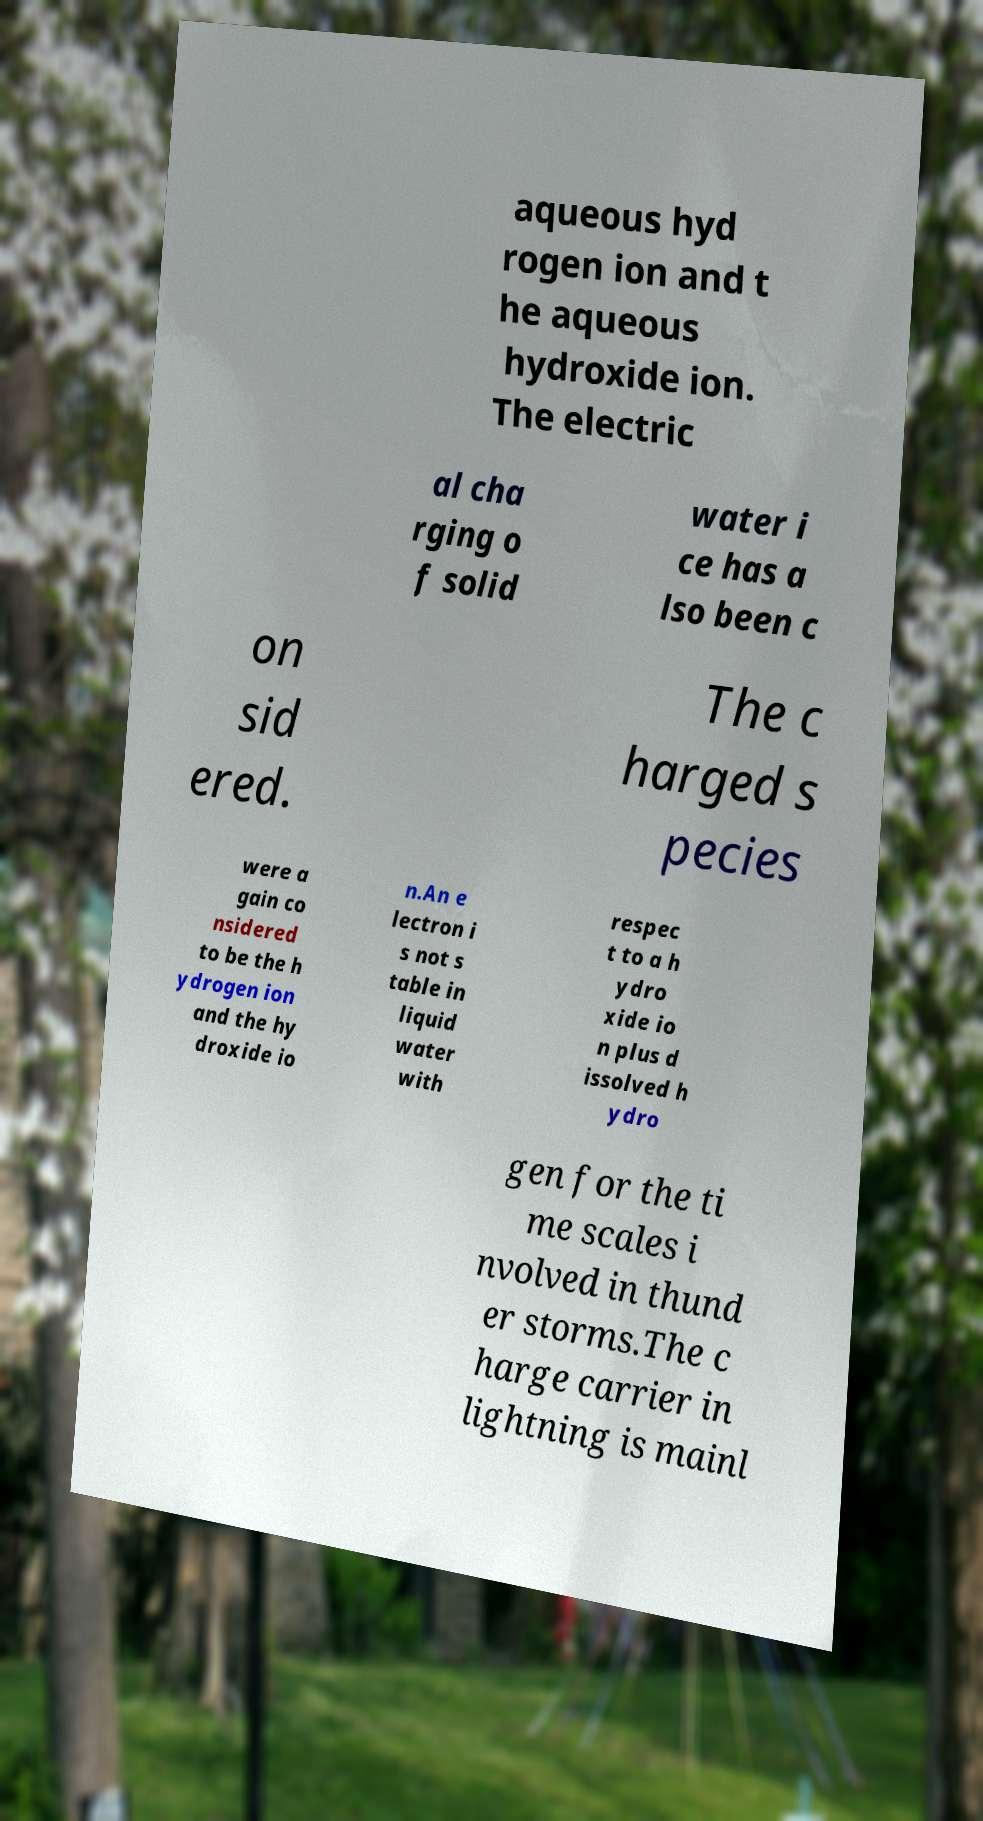Can you read and provide the text displayed in the image?This photo seems to have some interesting text. Can you extract and type it out for me? aqueous hyd rogen ion and t he aqueous hydroxide ion. The electric al cha rging o f solid water i ce has a lso been c on sid ered. The c harged s pecies were a gain co nsidered to be the h ydrogen ion and the hy droxide io n.An e lectron i s not s table in liquid water with respec t to a h ydro xide io n plus d issolved h ydro gen for the ti me scales i nvolved in thund er storms.The c harge carrier in lightning is mainl 